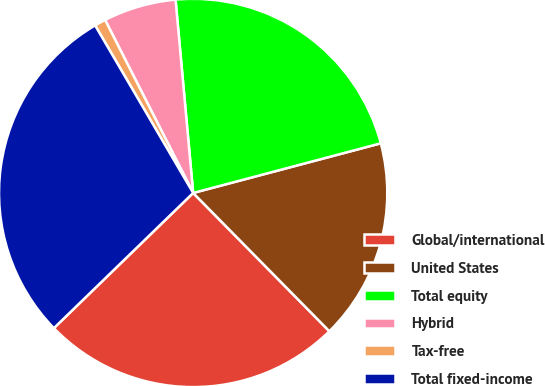Convert chart to OTSL. <chart><loc_0><loc_0><loc_500><loc_500><pie_chart><fcel>Global/international<fcel>United States<fcel>Total equity<fcel>Hybrid<fcel>Tax-free<fcel>Total fixed-income<nl><fcel>25.12%<fcel>16.74%<fcel>22.33%<fcel>6.05%<fcel>0.93%<fcel>28.84%<nl></chart> 